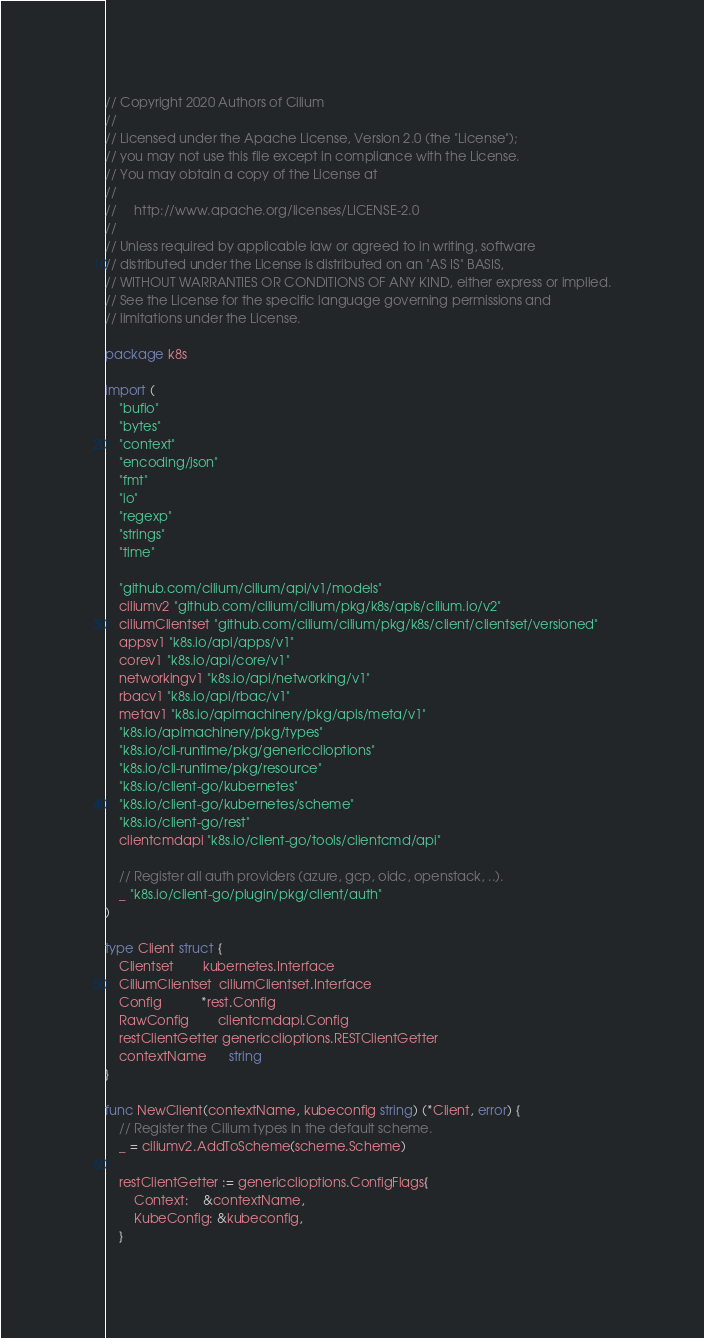Convert code to text. <code><loc_0><loc_0><loc_500><loc_500><_Go_>// Copyright 2020 Authors of Cilium
//
// Licensed under the Apache License, Version 2.0 (the "License");
// you may not use this file except in compliance with the License.
// You may obtain a copy of the License at
//
//     http://www.apache.org/licenses/LICENSE-2.0
//
// Unless required by applicable law or agreed to in writing, software
// distributed under the License is distributed on an "AS IS" BASIS,
// WITHOUT WARRANTIES OR CONDITIONS OF ANY KIND, either express or implied.
// See the License for the specific language governing permissions and
// limitations under the License.

package k8s

import (
	"bufio"
	"bytes"
	"context"
	"encoding/json"
	"fmt"
	"io"
	"regexp"
	"strings"
	"time"

	"github.com/cilium/cilium/api/v1/models"
	ciliumv2 "github.com/cilium/cilium/pkg/k8s/apis/cilium.io/v2"
	ciliumClientset "github.com/cilium/cilium/pkg/k8s/client/clientset/versioned"
	appsv1 "k8s.io/api/apps/v1"
	corev1 "k8s.io/api/core/v1"
	networkingv1 "k8s.io/api/networking/v1"
	rbacv1 "k8s.io/api/rbac/v1"
	metav1 "k8s.io/apimachinery/pkg/apis/meta/v1"
	"k8s.io/apimachinery/pkg/types"
	"k8s.io/cli-runtime/pkg/genericclioptions"
	"k8s.io/cli-runtime/pkg/resource"
	"k8s.io/client-go/kubernetes"
	"k8s.io/client-go/kubernetes/scheme"
	"k8s.io/client-go/rest"
	clientcmdapi "k8s.io/client-go/tools/clientcmd/api"

	// Register all auth providers (azure, gcp, oidc, openstack, ..).
	_ "k8s.io/client-go/plugin/pkg/client/auth"
)

type Client struct {
	Clientset        kubernetes.Interface
	CiliumClientset  ciliumClientset.Interface
	Config           *rest.Config
	RawConfig        clientcmdapi.Config
	restClientGetter genericclioptions.RESTClientGetter
	contextName      string
}

func NewClient(contextName, kubeconfig string) (*Client, error) {
	// Register the Cilium types in the default scheme.
	_ = ciliumv2.AddToScheme(scheme.Scheme)

	restClientGetter := genericclioptions.ConfigFlags{
		Context:    &contextName,
		KubeConfig: &kubeconfig,
	}</code> 